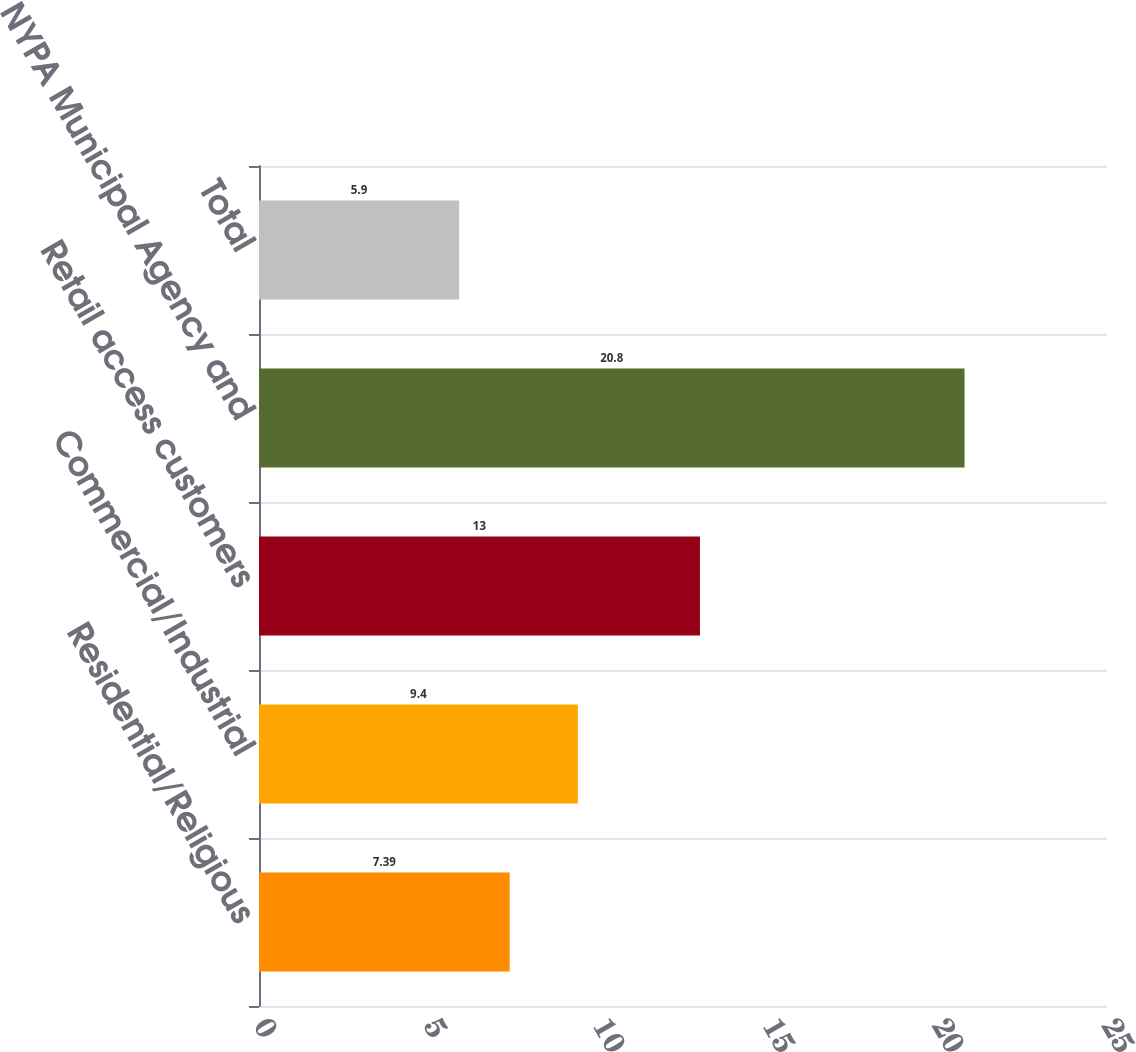Convert chart to OTSL. <chart><loc_0><loc_0><loc_500><loc_500><bar_chart><fcel>Residential/Religious<fcel>Commercial/Industrial<fcel>Retail access customers<fcel>NYPA Municipal Agency and<fcel>Total<nl><fcel>7.39<fcel>9.4<fcel>13<fcel>20.8<fcel>5.9<nl></chart> 